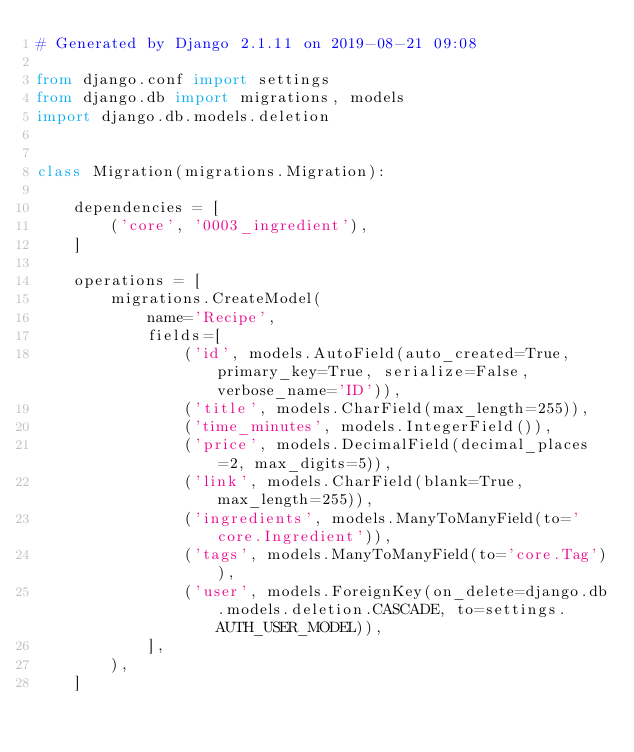Convert code to text. <code><loc_0><loc_0><loc_500><loc_500><_Python_># Generated by Django 2.1.11 on 2019-08-21 09:08

from django.conf import settings
from django.db import migrations, models
import django.db.models.deletion


class Migration(migrations.Migration):

    dependencies = [
        ('core', '0003_ingredient'),
    ]

    operations = [
        migrations.CreateModel(
            name='Recipe',
            fields=[
                ('id', models.AutoField(auto_created=True, primary_key=True, serialize=False, verbose_name='ID')),
                ('title', models.CharField(max_length=255)),
                ('time_minutes', models.IntegerField()),
                ('price', models.DecimalField(decimal_places=2, max_digits=5)),
                ('link', models.CharField(blank=True, max_length=255)),
                ('ingredients', models.ManyToManyField(to='core.Ingredient')),
                ('tags', models.ManyToManyField(to='core.Tag')),
                ('user', models.ForeignKey(on_delete=django.db.models.deletion.CASCADE, to=settings.AUTH_USER_MODEL)),
            ],
        ),
    ]
</code> 